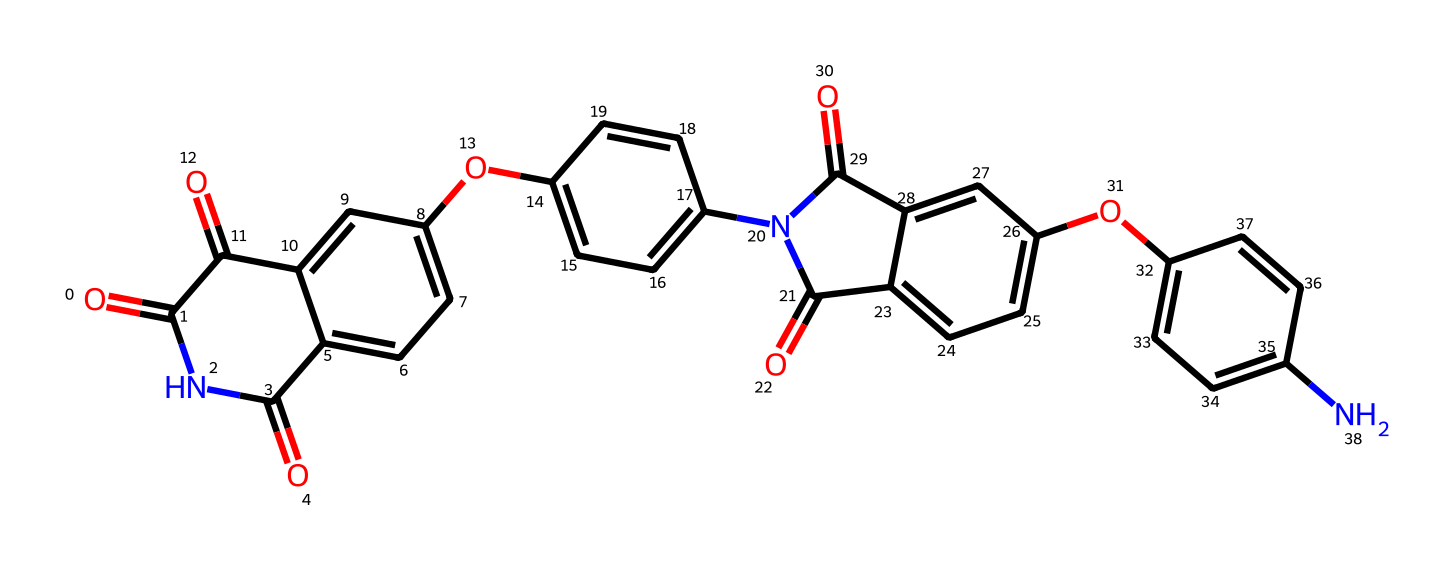What is the molecular formula of polyimide represented here? To determine the molecular formula from the provided SMILES notation, one needs to identify each atom type and count them. By decoding the SMILES representation, we can find the counts of carbon (C), hydrogen (H), nitrogen (N), and oxygen (O) atoms in the structure. In this case, we find that there are 22 carbons, 12 hydrogens, 4 nitrogens, and 5 oxygens. Therefore, the molecular formula is C22H12N4O5.
Answer: C22H12N4O5 How many nitrogen atoms are in this polyimide structure? From the SMILES representation, we can see that there are specific groups where nitrogen atoms appear. By counting these groups in the chemical structure, we determine that there are 4 nitrogen atoms present in polyimide.
Answer: 4 What type of polymer is polyimide classified as? Polyimide is classified as a thermosetting polymer, which is known for its heat-resistant properties, making it particularly suitable for aerospace applications. The structure contains amide linkages which characterize polyimides.
Answer: thermosetting Does this polyimide structure contain aromatic rings? The presence of benzene-like rings can be inferred in the SMILES through the notation 'c' indicating aromatic carbon atoms. By examining the structural components, we find multiple aromatic rings integrated in the polyimide chemical structure.
Answer: yes What is one of the main applications of polyimide? Polyimide's properties make it highly suitable for use in aerospace applications, such as insulation materials in spacecraft due to their exceptional thermal stability.
Answer: insulation materials 